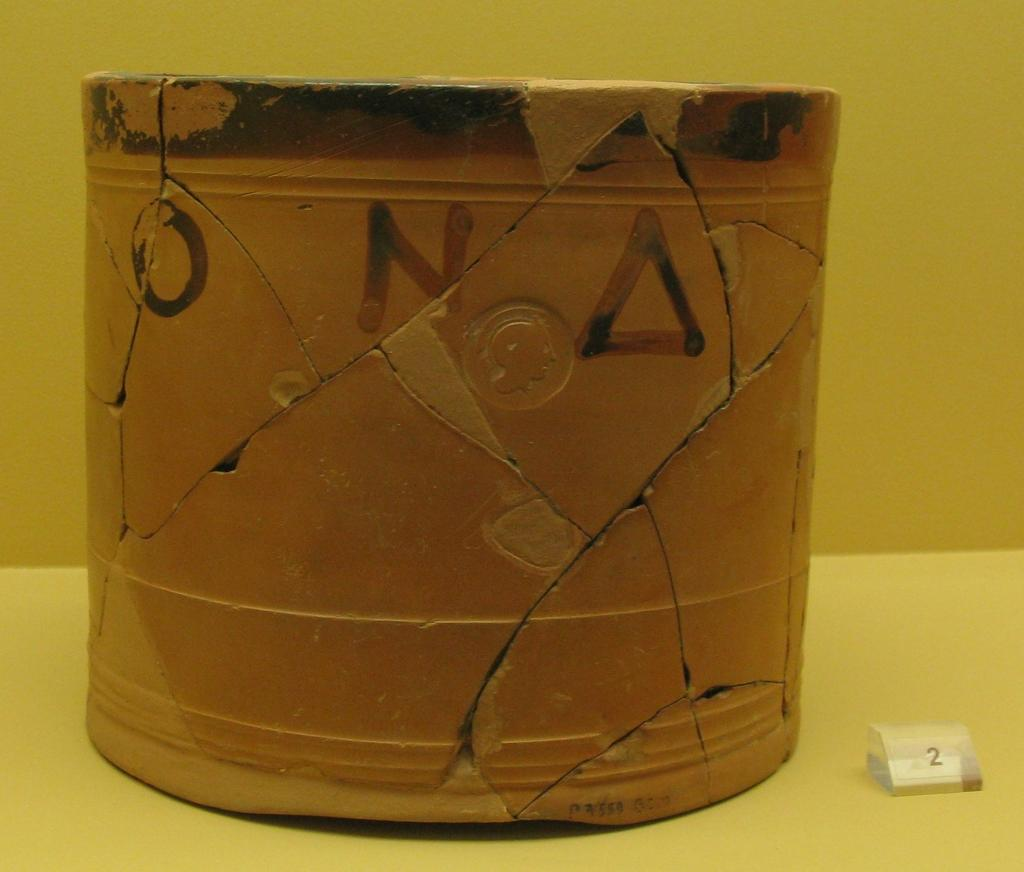<image>
Present a compact description of the photo's key features. A cracked pot with the letters O, N and a triangle 